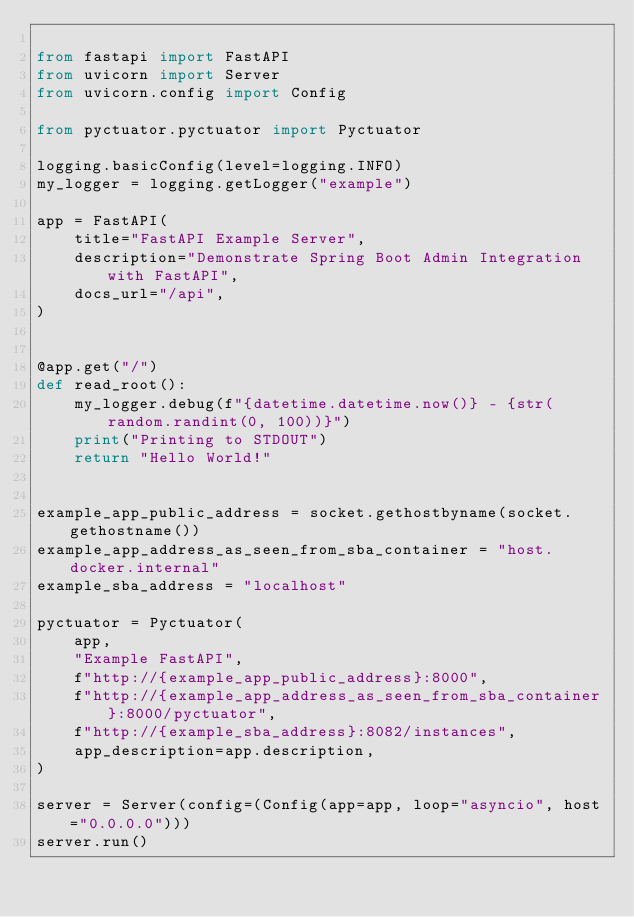<code> <loc_0><loc_0><loc_500><loc_500><_Python_>
from fastapi import FastAPI
from uvicorn import Server
from uvicorn.config import Config

from pyctuator.pyctuator import Pyctuator

logging.basicConfig(level=logging.INFO)
my_logger = logging.getLogger("example")

app = FastAPI(
    title="FastAPI Example Server",
    description="Demonstrate Spring Boot Admin Integration with FastAPI",
    docs_url="/api",
)


@app.get("/")
def read_root():
    my_logger.debug(f"{datetime.datetime.now()} - {str(random.randint(0, 100))}")
    print("Printing to STDOUT")
    return "Hello World!"


example_app_public_address = socket.gethostbyname(socket.gethostname())
example_app_address_as_seen_from_sba_container = "host.docker.internal"
example_sba_address = "localhost"

pyctuator = Pyctuator(
    app,
    "Example FastAPI",
    f"http://{example_app_public_address}:8000",
    f"http://{example_app_address_as_seen_from_sba_container}:8000/pyctuator",
    f"http://{example_sba_address}:8082/instances",
    app_description=app.description,
)

server = Server(config=(Config(app=app, loop="asyncio", host="0.0.0.0")))
server.run()
</code> 